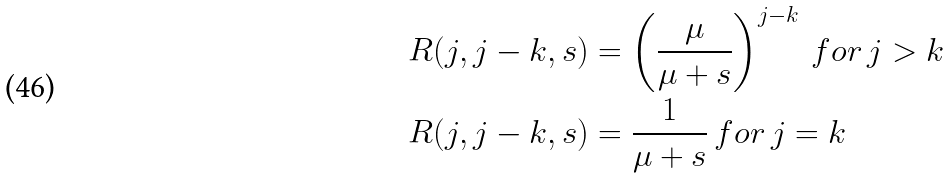Convert formula to latex. <formula><loc_0><loc_0><loc_500><loc_500>R ( j , j - k , s ) & = \left ( \frac { \mu } { \mu + s } \right ) ^ { j - k } \, f o r \, j > k \\ R ( j , j - k , s ) & = \frac { 1 } { \mu + s } \, f o r \, j = k</formula> 